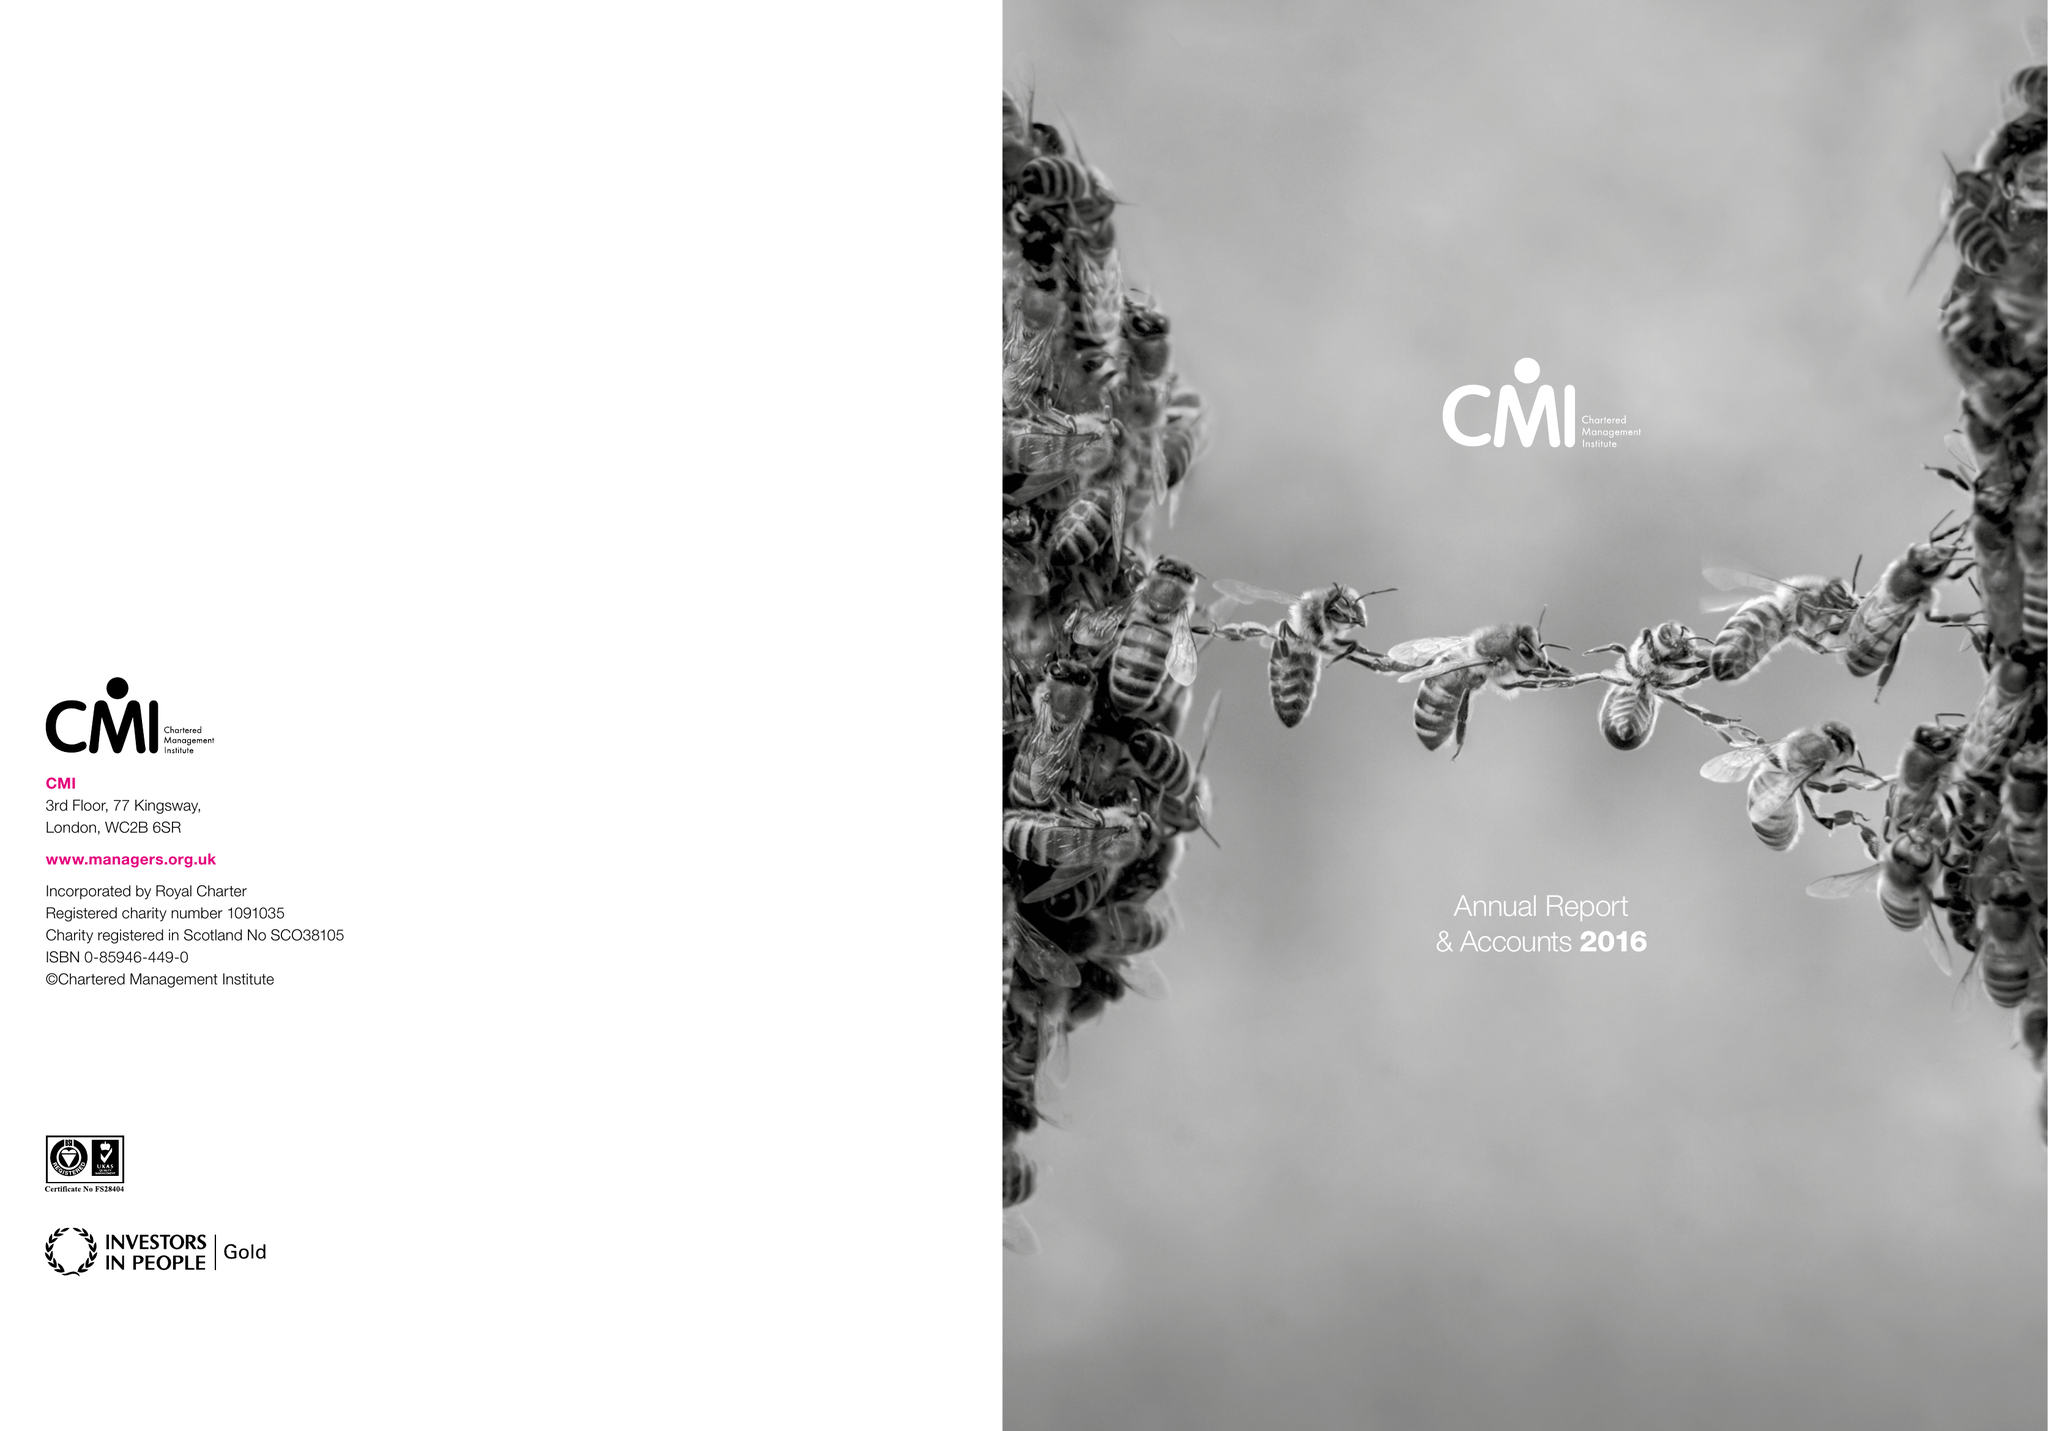What is the value for the spending_annually_in_british_pounds?
Answer the question using a single word or phrase. 11841000.00 